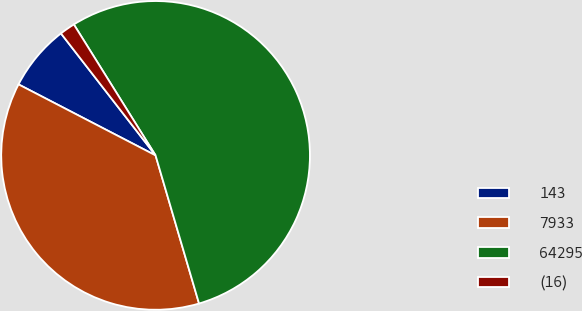<chart> <loc_0><loc_0><loc_500><loc_500><pie_chart><fcel>143<fcel>7933<fcel>64295<fcel>(16)<nl><fcel>6.89%<fcel>37.15%<fcel>54.33%<fcel>1.62%<nl></chart> 